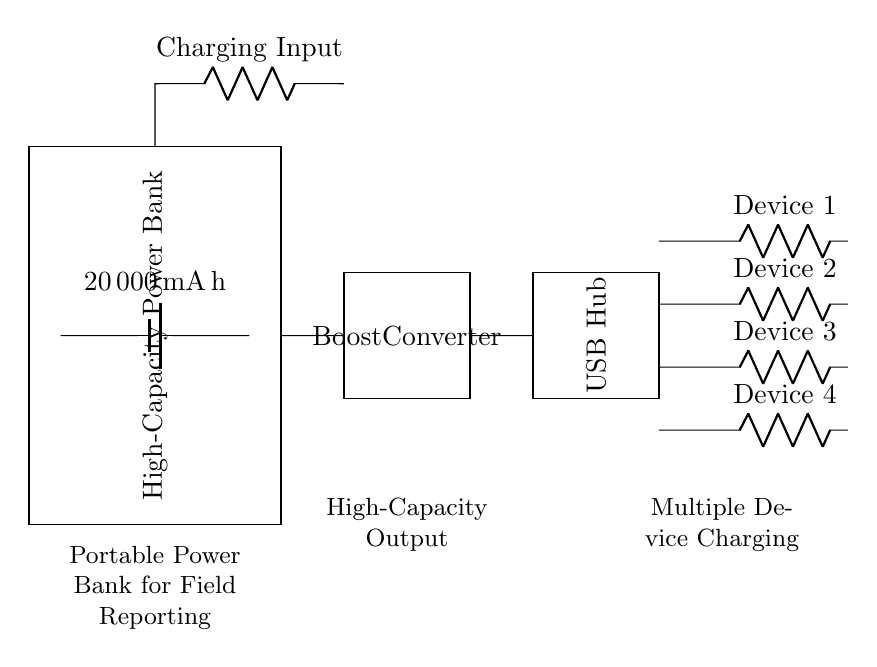What is the capacity of the battery in the power bank? The battery is labeled with a capacity of 20000 milliampere-hour, indicating how much charge it can hold.
Answer: 20000 milliampere-hour What function does the boost converter serve in this circuit? The boost converter increases the voltage from the battery to a higher level suitable for charging multiple devices, thus providing a higher output power.
Answer: Increases voltage How many USB outputs are available for charging devices? There are four USB output ports labeled Device 1, Device 2, Device 3, and Device 4, allowing four devices to be charged simultaneously.
Answer: Four What is the main component responsible for charging the power bank? The circuit indicates a component labeled as Charging Input, which is where the external power source connects to charge the battery.
Answer: Charging Input Why is a USB hub included in this circuit? The USB hub allows for multiple USB outputs to be connected, enabling simultaneous charging of several devices from the single output of the boost converter.
Answer: To allow multiple device charging What type of device is the entire circuit designed for? The circuit is specifically designed for a portable power bank, as indicated in the label stating it is for field reporting and high-capacity output.
Answer: Portable power bank What is the primary application for using this power bank? The power bank is primarily intended for field reporting, allowing journalists to charge multiple devices while on location away from regular power sources.
Answer: Field reporting 